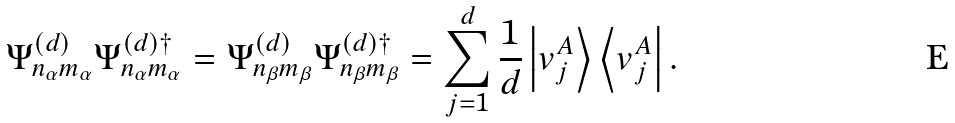<formula> <loc_0><loc_0><loc_500><loc_500>\Psi _ { n _ { \alpha } m _ { \alpha } } ^ { ( d ) } \Psi _ { n _ { \alpha } m _ { \alpha } } ^ { ( d ) \dagger } = \Psi _ { n _ { \beta } m _ { \beta } } ^ { ( d ) } \Psi _ { n _ { \beta } m _ { \beta } } ^ { ( d ) \dagger } = \sum _ { j = 1 } ^ { d } \frac { 1 } { d } \left | v _ { j } ^ { A } \right \rangle \left \langle v _ { j } ^ { A } \right | .</formula> 